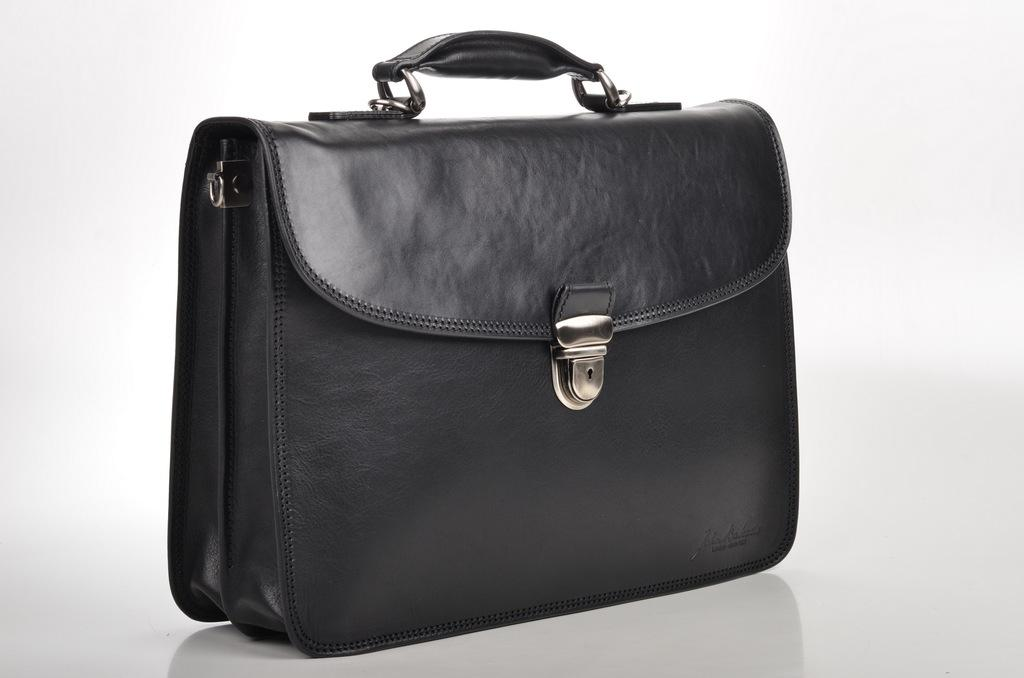What object is present in the image? There is a bag in the image. What type of teaching method is being demonstrated with the bag in the image? There is no teaching method or demonstration present in the image; it only features a bag. What type of blade is associated with the bag in the image? There is no blade present in the image; it only features a bag. 